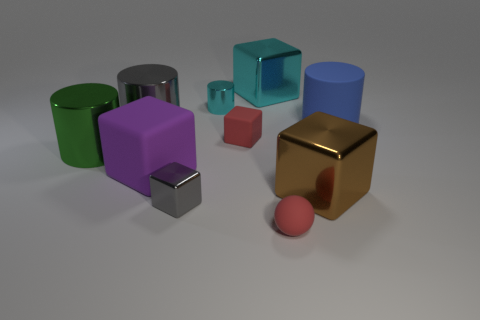Is the color of the tiny matte cube the same as the tiny matte ball?
Keep it short and to the point. Yes. There is a object that is the same color as the small metallic block; what material is it?
Offer a very short reply. Metal. How many blocks have the same color as the tiny shiny cylinder?
Provide a short and direct response. 1. There is a large block behind the large gray metallic cylinder; does it have the same color as the metallic cylinder behind the large blue cylinder?
Offer a terse response. Yes. Is there any other thing of the same color as the small rubber block?
Offer a terse response. Yes. There is a big shiny cylinder that is behind the green shiny object; does it have the same color as the small metallic block?
Offer a very short reply. Yes. How many blocks are big purple matte things or big brown shiny things?
Make the answer very short. 2. There is a gray thing behind the red object that is left of the matte sphere; what is its shape?
Your answer should be compact. Cylinder. There is a red matte thing in front of the large shiny cube that is on the right side of the red object that is in front of the brown metal block; how big is it?
Your answer should be very brief. Small. Does the brown thing have the same size as the green thing?
Make the answer very short. Yes. 